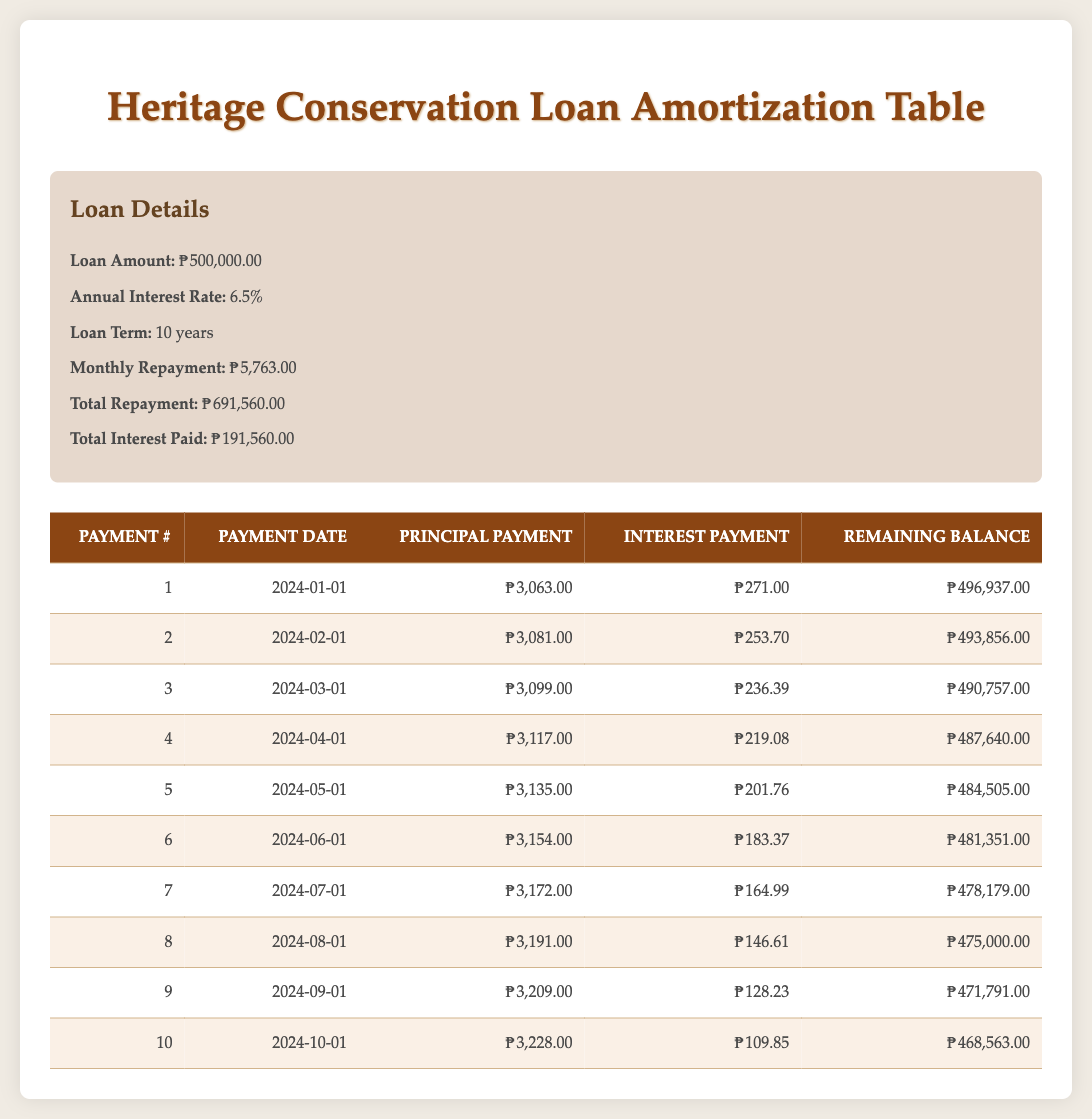What is the total loan amount taken for the community development initiatives? The table lists the loan amount explicitly in the loan details section. The loan amount is shown as 500,000.00.
Answer: 500,000.00 How much is the monthly repayment for the loan? The table directly indicates the monthly repayment under the loan details section, which is 5,763.00.
Answer: 5,763.00 What is the total interest paid over the term of the loan? The total interest paid is mentioned in the loan details section of the table as 191,560.00.
Answer: 191,560.00 What will the remaining balance be after the first payment? The remaining balance after the first payment is explicitly listed in the repayment schedule as 496,937.00.
Answer: 496,937.00 Is the principal payment for the 10th payment larger than the principal payment for the 1st payment? Comparing the principal payments, the 10th payment is noted as 3,228.00 and the 1st payment as 3,063.00; since 3,228.00 is greater than 3,063.00, the statement is true.
Answer: Yes How much interest is paid in the 5th payment? The interest payment for the 5th payment is clearly stated in the repayment schedule as 201.76.
Answer: 201.76 What is the average principal payment for the first five payments? To find the average, sum the principal payments from the first five payments: 3,063.00 + 3,081.00 + 3,099.00 + 3,117.00 + 3,135.00 = 15,495.00. Dividing by 5 gives an average of 3,099.00.
Answer: 3,099.00 What is the total repayment amount compared to the loan amount? The total repayment is 691,560.00, and the loan amount is 500,000.00. The total repayment is greater than the loan amount, indicating that interest is being paid.
Answer: Total repayment is greater What is the difference between the interest paid in the 2nd and 3rd payments? The interest paid in the 2nd payment is 253.70 and in the 3rd payment is 236.39. The difference is calculated as 253.70 - 236.39 = 17.31.
Answer: 17.31 How much will be left to pay after the 6th payment? The remaining balance after the 6th payment is found in the repayment schedule, which states it as 481,351.00.
Answer: 481,351.00 